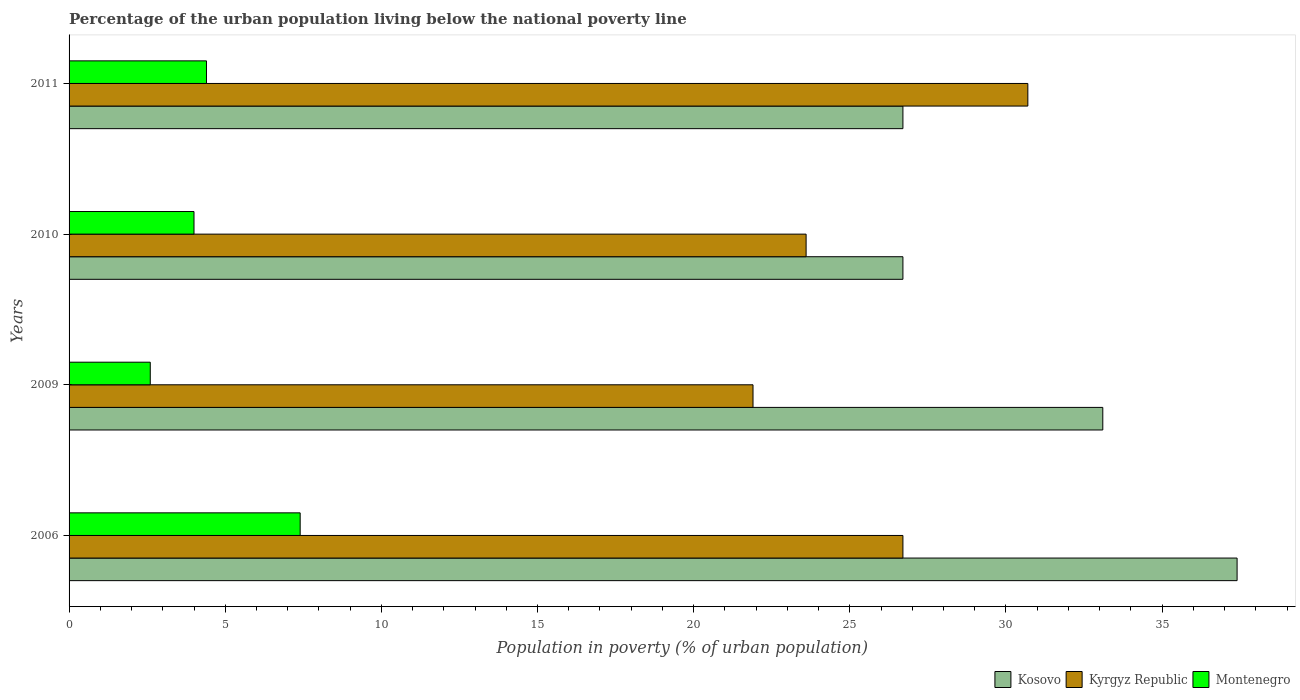How many different coloured bars are there?
Offer a very short reply. 3. Are the number of bars per tick equal to the number of legend labels?
Give a very brief answer. Yes. How many bars are there on the 2nd tick from the top?
Your answer should be very brief. 3. What is the label of the 4th group of bars from the top?
Your answer should be very brief. 2006. Across all years, what is the maximum percentage of the urban population living below the national poverty line in Kyrgyz Republic?
Provide a short and direct response. 30.7. Across all years, what is the minimum percentage of the urban population living below the national poverty line in Kyrgyz Republic?
Offer a terse response. 21.9. In which year was the percentage of the urban population living below the national poverty line in Kosovo maximum?
Offer a terse response. 2006. What is the difference between the percentage of the urban population living below the national poverty line in Kyrgyz Republic in 2006 and that in 2010?
Offer a very short reply. 3.1. What is the difference between the percentage of the urban population living below the national poverty line in Kosovo in 2010 and the percentage of the urban population living below the national poverty line in Montenegro in 2009?
Your answer should be compact. 24.1. In how many years, is the percentage of the urban population living below the national poverty line in Montenegro greater than 38 %?
Provide a short and direct response. 0. Is the difference between the percentage of the urban population living below the national poverty line in Kosovo in 2009 and 2010 greater than the difference between the percentage of the urban population living below the national poverty line in Montenegro in 2009 and 2010?
Your answer should be compact. Yes. In how many years, is the percentage of the urban population living below the national poverty line in Kyrgyz Republic greater than the average percentage of the urban population living below the national poverty line in Kyrgyz Republic taken over all years?
Give a very brief answer. 2. What does the 2nd bar from the top in 2010 represents?
Keep it short and to the point. Kyrgyz Republic. What does the 2nd bar from the bottom in 2006 represents?
Make the answer very short. Kyrgyz Republic. Is it the case that in every year, the sum of the percentage of the urban population living below the national poverty line in Kyrgyz Republic and percentage of the urban population living below the national poverty line in Montenegro is greater than the percentage of the urban population living below the national poverty line in Kosovo?
Offer a terse response. No. Are all the bars in the graph horizontal?
Your answer should be compact. Yes. What is the difference between two consecutive major ticks on the X-axis?
Offer a very short reply. 5. Are the values on the major ticks of X-axis written in scientific E-notation?
Your response must be concise. No. Does the graph contain any zero values?
Make the answer very short. No. Does the graph contain grids?
Offer a terse response. No. Where does the legend appear in the graph?
Offer a very short reply. Bottom right. What is the title of the graph?
Make the answer very short. Percentage of the urban population living below the national poverty line. Does "Netherlands" appear as one of the legend labels in the graph?
Make the answer very short. No. What is the label or title of the X-axis?
Keep it short and to the point. Population in poverty (% of urban population). What is the label or title of the Y-axis?
Provide a succinct answer. Years. What is the Population in poverty (% of urban population) in Kosovo in 2006?
Your answer should be very brief. 37.4. What is the Population in poverty (% of urban population) of Kyrgyz Republic in 2006?
Provide a succinct answer. 26.7. What is the Population in poverty (% of urban population) of Montenegro in 2006?
Keep it short and to the point. 7.4. What is the Population in poverty (% of urban population) of Kosovo in 2009?
Keep it short and to the point. 33.1. What is the Population in poverty (% of urban population) of Kyrgyz Republic in 2009?
Your answer should be compact. 21.9. What is the Population in poverty (% of urban population) in Montenegro in 2009?
Your answer should be very brief. 2.6. What is the Population in poverty (% of urban population) of Kosovo in 2010?
Give a very brief answer. 26.7. What is the Population in poverty (% of urban population) in Kyrgyz Republic in 2010?
Your answer should be very brief. 23.6. What is the Population in poverty (% of urban population) of Montenegro in 2010?
Give a very brief answer. 4. What is the Population in poverty (% of urban population) in Kosovo in 2011?
Provide a succinct answer. 26.7. What is the Population in poverty (% of urban population) of Kyrgyz Republic in 2011?
Provide a succinct answer. 30.7. Across all years, what is the maximum Population in poverty (% of urban population) of Kosovo?
Your answer should be compact. 37.4. Across all years, what is the maximum Population in poverty (% of urban population) of Kyrgyz Republic?
Ensure brevity in your answer.  30.7. Across all years, what is the maximum Population in poverty (% of urban population) of Montenegro?
Ensure brevity in your answer.  7.4. Across all years, what is the minimum Population in poverty (% of urban population) of Kosovo?
Your response must be concise. 26.7. Across all years, what is the minimum Population in poverty (% of urban population) in Kyrgyz Republic?
Provide a short and direct response. 21.9. What is the total Population in poverty (% of urban population) in Kosovo in the graph?
Your answer should be compact. 123.9. What is the total Population in poverty (% of urban population) of Kyrgyz Republic in the graph?
Give a very brief answer. 102.9. What is the difference between the Population in poverty (% of urban population) of Kosovo in 2006 and that in 2009?
Offer a very short reply. 4.3. What is the difference between the Population in poverty (% of urban population) in Kyrgyz Republic in 2006 and that in 2009?
Your answer should be very brief. 4.8. What is the difference between the Population in poverty (% of urban population) in Montenegro in 2006 and that in 2009?
Offer a terse response. 4.8. What is the difference between the Population in poverty (% of urban population) in Kosovo in 2006 and that in 2010?
Keep it short and to the point. 10.7. What is the difference between the Population in poverty (% of urban population) in Kosovo in 2006 and that in 2011?
Give a very brief answer. 10.7. What is the difference between the Population in poverty (% of urban population) of Kyrgyz Republic in 2006 and that in 2011?
Provide a succinct answer. -4. What is the difference between the Population in poverty (% of urban population) of Kosovo in 2006 and the Population in poverty (% of urban population) of Kyrgyz Republic in 2009?
Your response must be concise. 15.5. What is the difference between the Population in poverty (% of urban population) in Kosovo in 2006 and the Population in poverty (% of urban population) in Montenegro in 2009?
Your response must be concise. 34.8. What is the difference between the Population in poverty (% of urban population) in Kyrgyz Republic in 2006 and the Population in poverty (% of urban population) in Montenegro in 2009?
Provide a succinct answer. 24.1. What is the difference between the Population in poverty (% of urban population) of Kosovo in 2006 and the Population in poverty (% of urban population) of Kyrgyz Republic in 2010?
Your response must be concise. 13.8. What is the difference between the Population in poverty (% of urban population) in Kosovo in 2006 and the Population in poverty (% of urban population) in Montenegro in 2010?
Keep it short and to the point. 33.4. What is the difference between the Population in poverty (% of urban population) in Kyrgyz Republic in 2006 and the Population in poverty (% of urban population) in Montenegro in 2010?
Your answer should be very brief. 22.7. What is the difference between the Population in poverty (% of urban population) of Kyrgyz Republic in 2006 and the Population in poverty (% of urban population) of Montenegro in 2011?
Make the answer very short. 22.3. What is the difference between the Population in poverty (% of urban population) in Kosovo in 2009 and the Population in poverty (% of urban population) in Kyrgyz Republic in 2010?
Offer a very short reply. 9.5. What is the difference between the Population in poverty (% of urban population) of Kosovo in 2009 and the Population in poverty (% of urban population) of Montenegro in 2010?
Your response must be concise. 29.1. What is the difference between the Population in poverty (% of urban population) in Kyrgyz Republic in 2009 and the Population in poverty (% of urban population) in Montenegro in 2010?
Your answer should be very brief. 17.9. What is the difference between the Population in poverty (% of urban population) in Kosovo in 2009 and the Population in poverty (% of urban population) in Montenegro in 2011?
Provide a short and direct response. 28.7. What is the difference between the Population in poverty (% of urban population) in Kosovo in 2010 and the Population in poverty (% of urban population) in Montenegro in 2011?
Your answer should be compact. 22.3. What is the average Population in poverty (% of urban population) in Kosovo per year?
Provide a succinct answer. 30.98. What is the average Population in poverty (% of urban population) in Kyrgyz Republic per year?
Keep it short and to the point. 25.73. In the year 2006, what is the difference between the Population in poverty (% of urban population) in Kosovo and Population in poverty (% of urban population) in Kyrgyz Republic?
Offer a very short reply. 10.7. In the year 2006, what is the difference between the Population in poverty (% of urban population) in Kosovo and Population in poverty (% of urban population) in Montenegro?
Offer a terse response. 30. In the year 2006, what is the difference between the Population in poverty (% of urban population) of Kyrgyz Republic and Population in poverty (% of urban population) of Montenegro?
Your answer should be compact. 19.3. In the year 2009, what is the difference between the Population in poverty (% of urban population) in Kosovo and Population in poverty (% of urban population) in Montenegro?
Your answer should be compact. 30.5. In the year 2009, what is the difference between the Population in poverty (% of urban population) of Kyrgyz Republic and Population in poverty (% of urban population) of Montenegro?
Keep it short and to the point. 19.3. In the year 2010, what is the difference between the Population in poverty (% of urban population) in Kosovo and Population in poverty (% of urban population) in Montenegro?
Keep it short and to the point. 22.7. In the year 2010, what is the difference between the Population in poverty (% of urban population) of Kyrgyz Republic and Population in poverty (% of urban population) of Montenegro?
Offer a very short reply. 19.6. In the year 2011, what is the difference between the Population in poverty (% of urban population) of Kosovo and Population in poverty (% of urban population) of Kyrgyz Republic?
Provide a short and direct response. -4. In the year 2011, what is the difference between the Population in poverty (% of urban population) in Kosovo and Population in poverty (% of urban population) in Montenegro?
Give a very brief answer. 22.3. In the year 2011, what is the difference between the Population in poverty (% of urban population) of Kyrgyz Republic and Population in poverty (% of urban population) of Montenegro?
Your answer should be compact. 26.3. What is the ratio of the Population in poverty (% of urban population) in Kosovo in 2006 to that in 2009?
Offer a very short reply. 1.13. What is the ratio of the Population in poverty (% of urban population) of Kyrgyz Republic in 2006 to that in 2009?
Keep it short and to the point. 1.22. What is the ratio of the Population in poverty (% of urban population) in Montenegro in 2006 to that in 2009?
Your answer should be very brief. 2.85. What is the ratio of the Population in poverty (% of urban population) in Kosovo in 2006 to that in 2010?
Give a very brief answer. 1.4. What is the ratio of the Population in poverty (% of urban population) of Kyrgyz Republic in 2006 to that in 2010?
Provide a short and direct response. 1.13. What is the ratio of the Population in poverty (% of urban population) of Montenegro in 2006 to that in 2010?
Offer a very short reply. 1.85. What is the ratio of the Population in poverty (% of urban population) in Kosovo in 2006 to that in 2011?
Offer a terse response. 1.4. What is the ratio of the Population in poverty (% of urban population) of Kyrgyz Republic in 2006 to that in 2011?
Ensure brevity in your answer.  0.87. What is the ratio of the Population in poverty (% of urban population) of Montenegro in 2006 to that in 2011?
Offer a very short reply. 1.68. What is the ratio of the Population in poverty (% of urban population) of Kosovo in 2009 to that in 2010?
Your response must be concise. 1.24. What is the ratio of the Population in poverty (% of urban population) in Kyrgyz Republic in 2009 to that in 2010?
Offer a terse response. 0.93. What is the ratio of the Population in poverty (% of urban population) in Montenegro in 2009 to that in 2010?
Your answer should be compact. 0.65. What is the ratio of the Population in poverty (% of urban population) in Kosovo in 2009 to that in 2011?
Your answer should be compact. 1.24. What is the ratio of the Population in poverty (% of urban population) of Kyrgyz Republic in 2009 to that in 2011?
Keep it short and to the point. 0.71. What is the ratio of the Population in poverty (% of urban population) in Montenegro in 2009 to that in 2011?
Offer a terse response. 0.59. What is the ratio of the Population in poverty (% of urban population) in Kosovo in 2010 to that in 2011?
Your response must be concise. 1. What is the ratio of the Population in poverty (% of urban population) in Kyrgyz Republic in 2010 to that in 2011?
Provide a succinct answer. 0.77. What is the difference between the highest and the second highest Population in poverty (% of urban population) in Kosovo?
Make the answer very short. 4.3. What is the difference between the highest and the lowest Population in poverty (% of urban population) of Kosovo?
Keep it short and to the point. 10.7. What is the difference between the highest and the lowest Population in poverty (% of urban population) in Kyrgyz Republic?
Provide a short and direct response. 8.8. What is the difference between the highest and the lowest Population in poverty (% of urban population) in Montenegro?
Offer a very short reply. 4.8. 